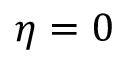<formula> <loc_0><loc_0><loc_500><loc_500>\eta = 0</formula> 